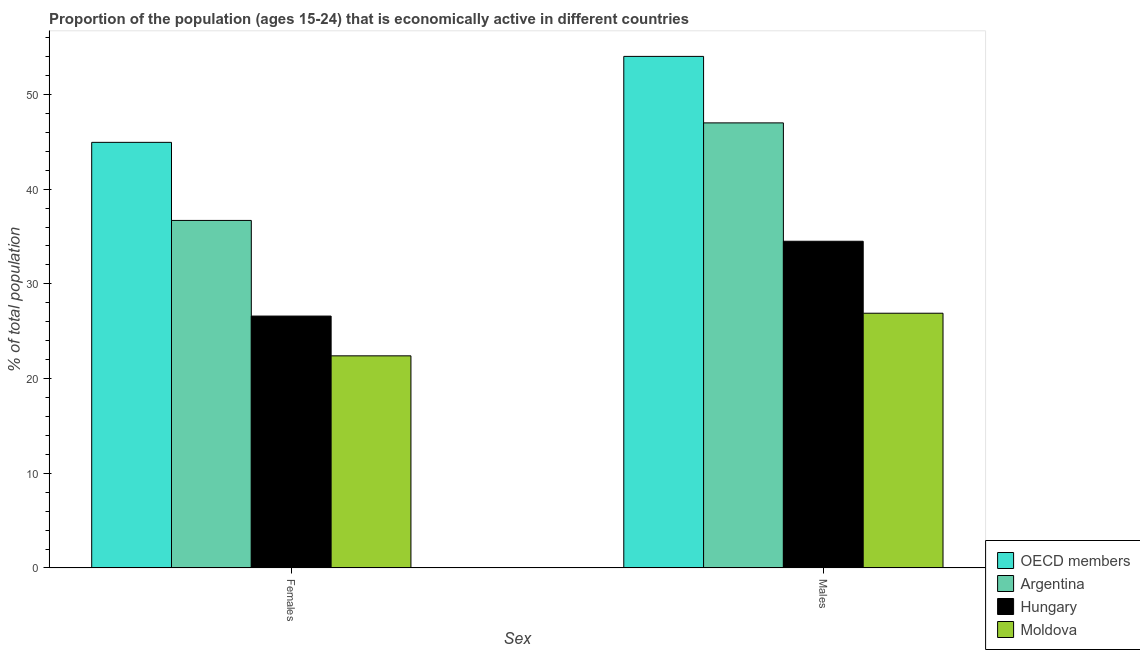How many different coloured bars are there?
Offer a terse response. 4. How many groups of bars are there?
Keep it short and to the point. 2. Are the number of bars per tick equal to the number of legend labels?
Keep it short and to the point. Yes. How many bars are there on the 2nd tick from the left?
Give a very brief answer. 4. What is the label of the 1st group of bars from the left?
Offer a terse response. Females. Across all countries, what is the maximum percentage of economically active male population?
Keep it short and to the point. 54.02. Across all countries, what is the minimum percentage of economically active female population?
Ensure brevity in your answer.  22.4. In which country was the percentage of economically active female population minimum?
Provide a succinct answer. Moldova. What is the total percentage of economically active male population in the graph?
Your answer should be compact. 162.42. What is the difference between the percentage of economically active male population in Argentina and that in Moldova?
Provide a succinct answer. 20.1. What is the difference between the percentage of economically active female population in Moldova and the percentage of economically active male population in Argentina?
Ensure brevity in your answer.  -24.6. What is the average percentage of economically active female population per country?
Your answer should be very brief. 32.66. What is the difference between the percentage of economically active male population and percentage of economically active female population in OECD members?
Your answer should be compact. 9.08. In how many countries, is the percentage of economically active male population greater than 8 %?
Your answer should be very brief. 4. What is the ratio of the percentage of economically active female population in OECD members to that in Hungary?
Provide a succinct answer. 1.69. Is the percentage of economically active male population in Hungary less than that in OECD members?
Keep it short and to the point. Yes. What does the 4th bar from the left in Males represents?
Provide a succinct answer. Moldova. Are all the bars in the graph horizontal?
Provide a succinct answer. No. How many countries are there in the graph?
Offer a terse response. 4. Are the values on the major ticks of Y-axis written in scientific E-notation?
Make the answer very short. No. Where does the legend appear in the graph?
Give a very brief answer. Bottom right. What is the title of the graph?
Your answer should be very brief. Proportion of the population (ages 15-24) that is economically active in different countries. What is the label or title of the X-axis?
Your answer should be compact. Sex. What is the label or title of the Y-axis?
Your response must be concise. % of total population. What is the % of total population of OECD members in Females?
Your response must be concise. 44.94. What is the % of total population in Argentina in Females?
Your answer should be compact. 36.7. What is the % of total population in Hungary in Females?
Give a very brief answer. 26.6. What is the % of total population in Moldova in Females?
Offer a terse response. 22.4. What is the % of total population of OECD members in Males?
Give a very brief answer. 54.02. What is the % of total population in Hungary in Males?
Offer a terse response. 34.5. What is the % of total population of Moldova in Males?
Your answer should be compact. 26.9. Across all Sex, what is the maximum % of total population in OECD members?
Give a very brief answer. 54.02. Across all Sex, what is the maximum % of total population of Argentina?
Offer a very short reply. 47. Across all Sex, what is the maximum % of total population in Hungary?
Your answer should be compact. 34.5. Across all Sex, what is the maximum % of total population of Moldova?
Ensure brevity in your answer.  26.9. Across all Sex, what is the minimum % of total population of OECD members?
Your answer should be compact. 44.94. Across all Sex, what is the minimum % of total population of Argentina?
Your response must be concise. 36.7. Across all Sex, what is the minimum % of total population in Hungary?
Provide a succinct answer. 26.6. Across all Sex, what is the minimum % of total population in Moldova?
Make the answer very short. 22.4. What is the total % of total population of OECD members in the graph?
Offer a terse response. 98.97. What is the total % of total population in Argentina in the graph?
Your response must be concise. 83.7. What is the total % of total population of Hungary in the graph?
Ensure brevity in your answer.  61.1. What is the total % of total population of Moldova in the graph?
Offer a very short reply. 49.3. What is the difference between the % of total population in OECD members in Females and that in Males?
Make the answer very short. -9.08. What is the difference between the % of total population of OECD members in Females and the % of total population of Argentina in Males?
Ensure brevity in your answer.  -2.06. What is the difference between the % of total population of OECD members in Females and the % of total population of Hungary in Males?
Ensure brevity in your answer.  10.44. What is the difference between the % of total population in OECD members in Females and the % of total population in Moldova in Males?
Your answer should be very brief. 18.04. What is the difference between the % of total population of Argentina in Females and the % of total population of Hungary in Males?
Your answer should be compact. 2.2. What is the difference between the % of total population of Hungary in Females and the % of total population of Moldova in Males?
Offer a very short reply. -0.3. What is the average % of total population in OECD members per Sex?
Keep it short and to the point. 49.48. What is the average % of total population in Argentina per Sex?
Make the answer very short. 41.85. What is the average % of total population of Hungary per Sex?
Provide a succinct answer. 30.55. What is the average % of total population of Moldova per Sex?
Provide a short and direct response. 24.65. What is the difference between the % of total population of OECD members and % of total population of Argentina in Females?
Provide a short and direct response. 8.24. What is the difference between the % of total population in OECD members and % of total population in Hungary in Females?
Offer a terse response. 18.34. What is the difference between the % of total population of OECD members and % of total population of Moldova in Females?
Give a very brief answer. 22.54. What is the difference between the % of total population of Argentina and % of total population of Hungary in Females?
Provide a succinct answer. 10.1. What is the difference between the % of total population in OECD members and % of total population in Argentina in Males?
Offer a terse response. 7.02. What is the difference between the % of total population of OECD members and % of total population of Hungary in Males?
Your response must be concise. 19.52. What is the difference between the % of total population of OECD members and % of total population of Moldova in Males?
Make the answer very short. 27.12. What is the difference between the % of total population in Argentina and % of total population in Moldova in Males?
Ensure brevity in your answer.  20.1. What is the ratio of the % of total population in OECD members in Females to that in Males?
Keep it short and to the point. 0.83. What is the ratio of the % of total population in Argentina in Females to that in Males?
Keep it short and to the point. 0.78. What is the ratio of the % of total population of Hungary in Females to that in Males?
Keep it short and to the point. 0.77. What is the ratio of the % of total population in Moldova in Females to that in Males?
Give a very brief answer. 0.83. What is the difference between the highest and the second highest % of total population of OECD members?
Offer a terse response. 9.08. What is the difference between the highest and the second highest % of total population of Argentina?
Give a very brief answer. 10.3. What is the difference between the highest and the lowest % of total population of OECD members?
Your answer should be compact. 9.08. What is the difference between the highest and the lowest % of total population in Argentina?
Ensure brevity in your answer.  10.3. 